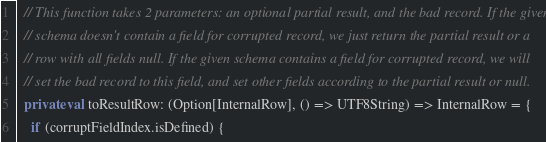<code> <loc_0><loc_0><loc_500><loc_500><_Scala_>  // This function takes 2 parameters: an optional partial result, and the bad record. If the given
  // schema doesn't contain a field for corrupted record, we just return the partial result or a
  // row with all fields null. If the given schema contains a field for corrupted record, we will
  // set the bad record to this field, and set other fields according to the partial result or null.
  private val toResultRow: (Option[InternalRow], () => UTF8String) => InternalRow = {
    if (corruptFieldIndex.isDefined) {</code> 